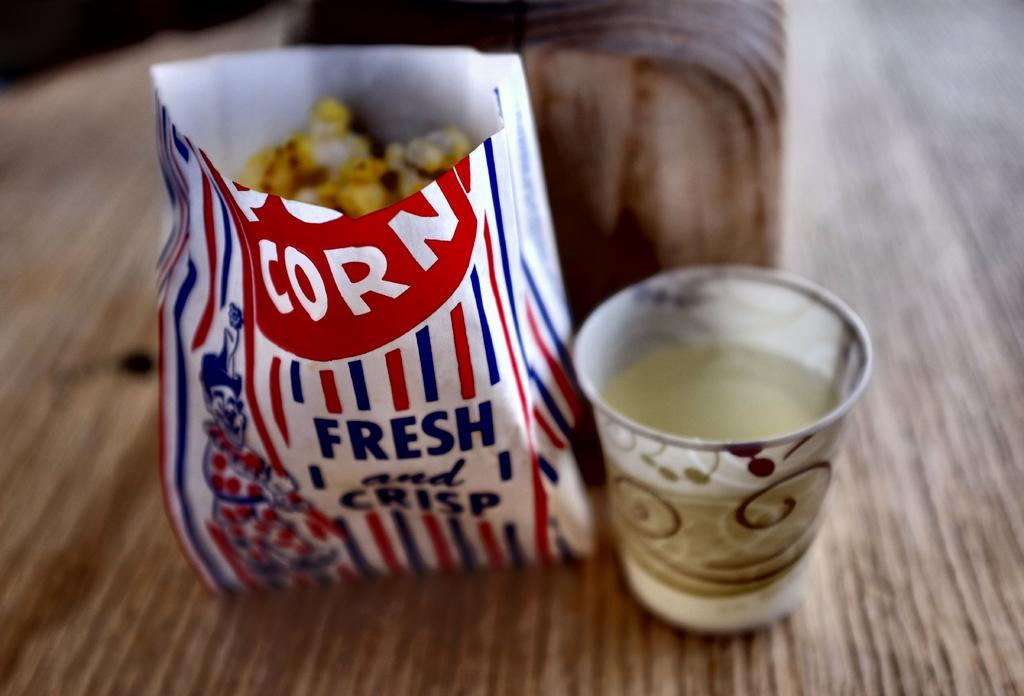What type of food item is visible in the image? There is a popcorn packet in the image. What is the other visible item in the image? There is a glass in the image. What color is the brown-colored item in the image? The brown-colored item in the image is not specified, but it is mentioned that the items are on a brown-colored surface. What is the color of the surface on which the items are placed? The items are on a brown-colored surface. Can you see a bee buzzing around the popcorn packet in the image? There is no bee present in the image. What type of yarn is being used to create the popcorn packet in the image? The popcorn packet is not made of yarn; it is a packaged food item. 